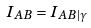Convert formula to latex. <formula><loc_0><loc_0><loc_500><loc_500>I _ { A B } = I _ { A B | \gamma }</formula> 